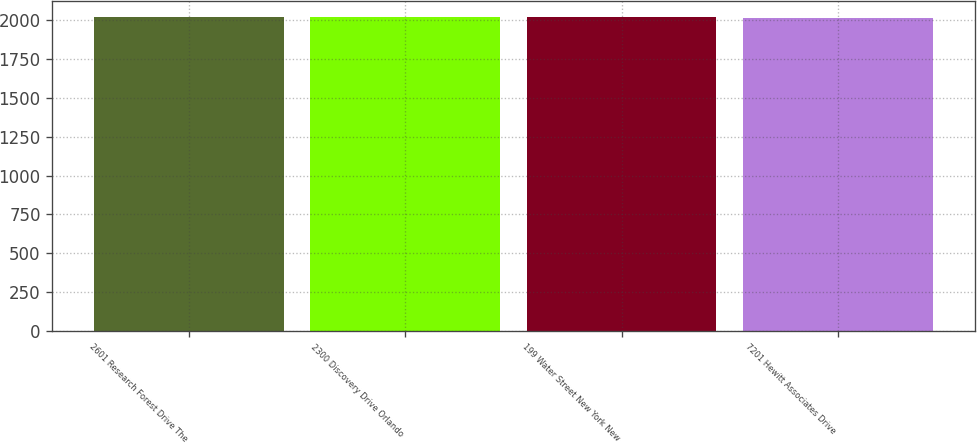Convert chart. <chart><loc_0><loc_0><loc_500><loc_500><bar_chart><fcel>2601 Research Forest Drive The<fcel>2300 Discovery Drive Orlando<fcel>199 Water Street New York New<fcel>7201 Hewitt Associates Drive<nl><fcel>2020<fcel>2020.5<fcel>2018<fcel>2015<nl></chart> 